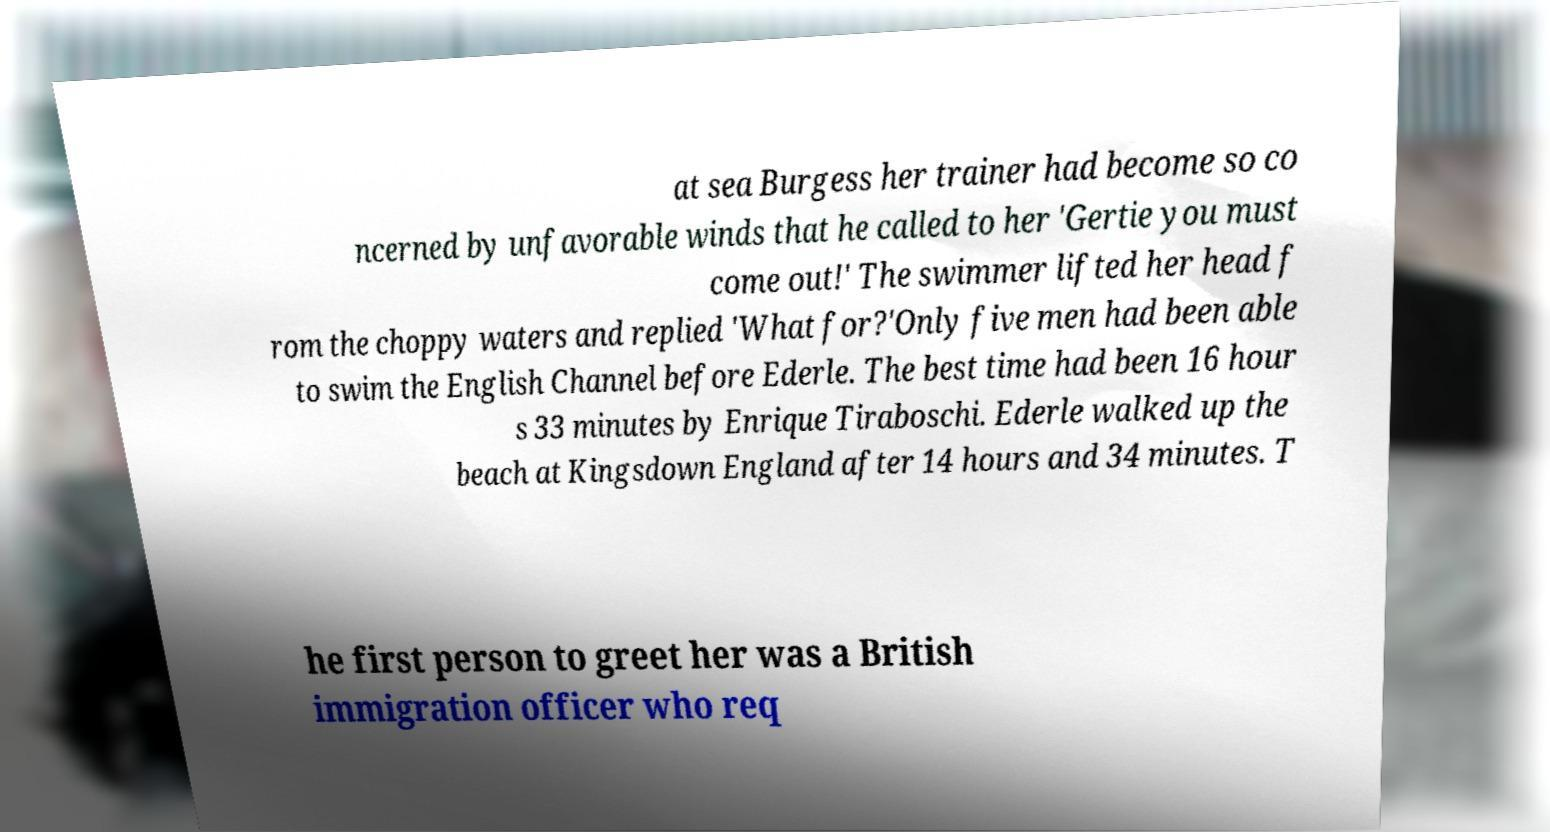Please read and relay the text visible in this image. What does it say? at sea Burgess her trainer had become so co ncerned by unfavorable winds that he called to her 'Gertie you must come out!' The swimmer lifted her head f rom the choppy waters and replied 'What for?'Only five men had been able to swim the English Channel before Ederle. The best time had been 16 hour s 33 minutes by Enrique Tiraboschi. Ederle walked up the beach at Kingsdown England after 14 hours and 34 minutes. T he first person to greet her was a British immigration officer who req 